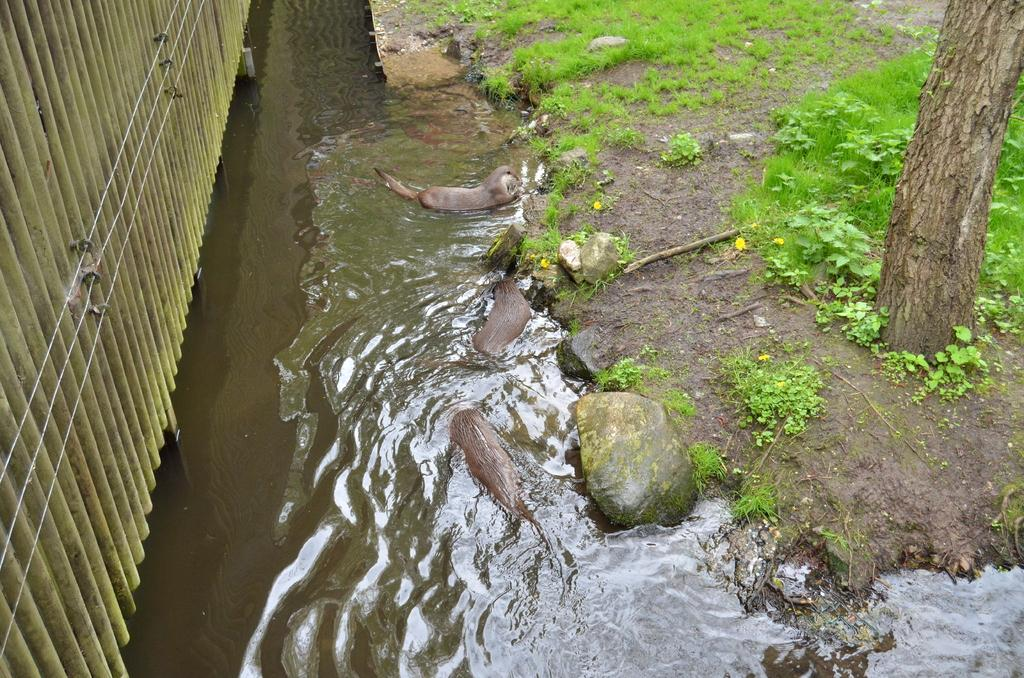What type of animals can be seen in the image? There are animals in the water. What else can be seen in the water besides the animals? There are rocks in the water. What can be seen in the background of the image? There is a tree, a group of plants, grass, and a fence with cables in the background. What type of nerve can be seen in the image? There is no nerve present in the image. How many owls can be seen in the image? There are no owls present in the image. 